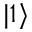<formula> <loc_0><loc_0><loc_500><loc_500>| 1 \rangle</formula> 